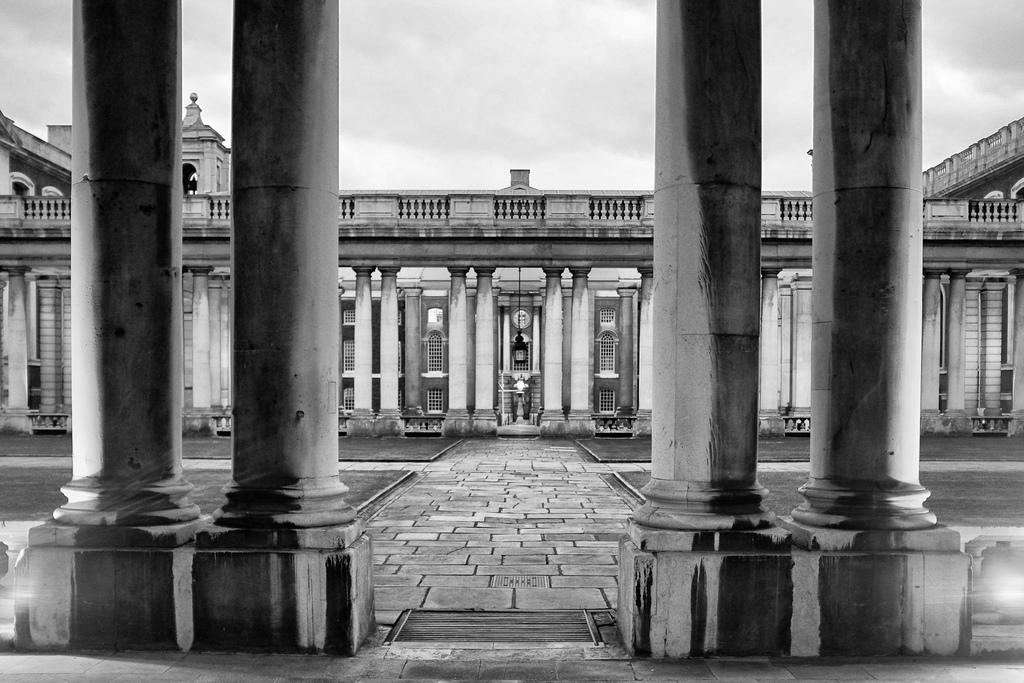What is the color scheme of the image? The image is black and white. What structures can be seen at the front of the image? There are pillars on either side in the front of the image. What is located behind the pillars? There is a building behind the pillars. What is in the middle of the image? There is a garden in the middle of the image. What can be seen above the garden? The sky is visible above the garden. What type of pipe is causing a traffic jam in the image? There is no pipe or traffic jam present in the image. 